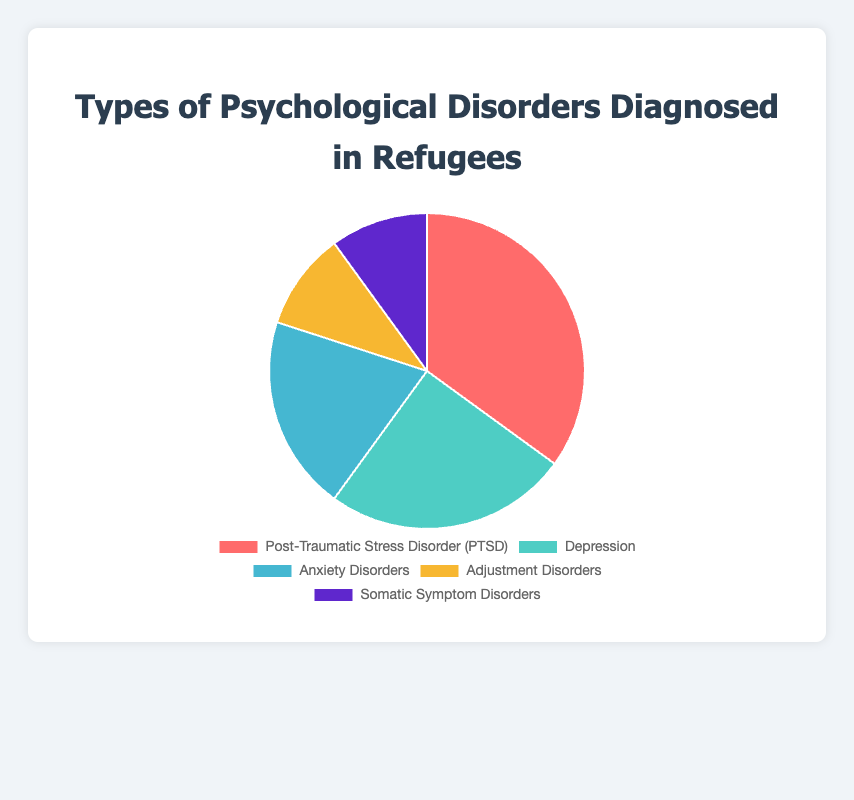Which psychological disorder is most commonly diagnosed in refugees? The figure shows the proportion of various psychological disorders. The largest slice represents the most common disorder, which is Post-Traumatic Stress Disorder (PTSD) at 35%.
Answer: Post-Traumatic Stress Disorder (PTSD) Which disorder has a larger percentage, Depression or Anxiety Disorders? Anxiety Disorders are represented by a slice indicating 20%, while Depression is represented by a larger slice indicating 25%. Therefore, Depression has a larger percentage.
Answer: Depression Are Adjustment Disorders and Somatic Symptom Disorders equally diagnosed? The chart has a slice for Adjustment Disorders and another for Somatic Symptom Disorders, both labeled with 10%. Thus, they are equally diagnosed.
Answer: Yes What is the combined percentage of Depression and Anxiety Disorders? The percentage for Depression is 25%, and for Anxiety Disorders is 20%. Adding these together, we get 25% + 20% = 45%.
Answer: 45% Which disorder is represented by the smallest segment of the pie chart? Both Adjustment Disorders and Somatic Symptom Disorders have the smallest segments, each covering 10%.
Answer: Adjustment Disorders and Somatic Symptom Disorders How much larger is the percentage of PTSD compared to Somatic Symptom Disorders? PTSD is represented by a slice indicating 35%, while Somatic Symptom Disorders are represented by a slice of 10%. Subtracting these, we find 35% - 10% = 25%.
Answer: 25% What percentage of diagnosed disorders is not PTSD? The figure shows PTSD at 35%. Subtracting from the total (100%), we get 100% - 35% = 65%.
Answer: 65% If one refugee is randomly selected, what is the probability that they have either Depression or Anxiety Disorders? Depression accounts for 25%, and Anxiety Disorders account for 20%. The probability of having either is the sum of these percentages, which is 25% + 20% = 45%.
Answer: 45% Which disorder is represented by the yellow segment? The yellow segment corresponds to Adjustment Disorders according to the figure.
Answer: Adjustment Disorders 